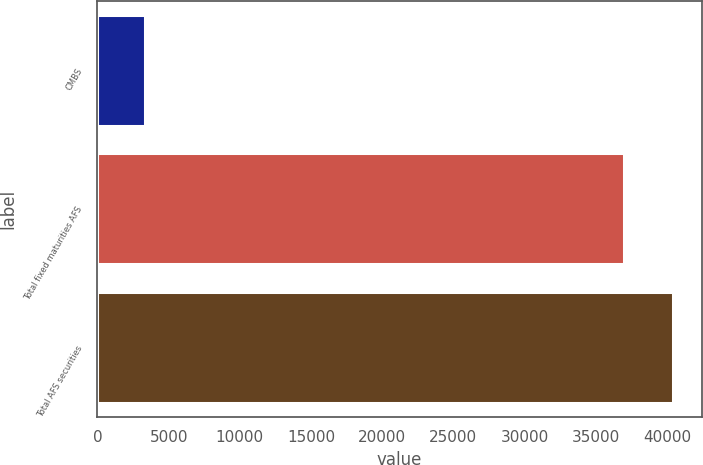Convert chart to OTSL. <chart><loc_0><loc_0><loc_500><loc_500><bar_chart><fcel>CMBS<fcel>Total fixed maturities AFS<fcel>Total AFS securities<nl><fcel>3336<fcel>36964<fcel>40428<nl></chart> 